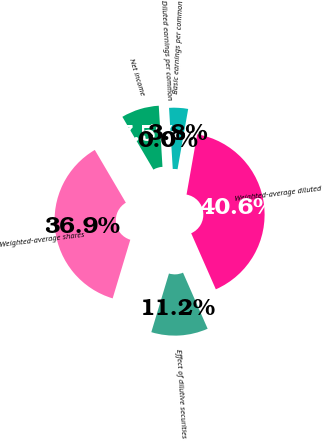Convert chart to OTSL. <chart><loc_0><loc_0><loc_500><loc_500><pie_chart><fcel>Net income<fcel>Weighted-average shares<fcel>Effect of dilutive securities<fcel>Weighted-average diluted<fcel>Basic earnings per common<fcel>Diluted earnings per common<nl><fcel>7.49%<fcel>36.89%<fcel>11.24%<fcel>40.63%<fcel>3.75%<fcel>0.0%<nl></chart> 